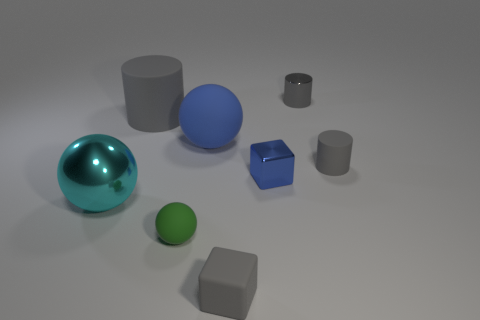Subtract all rubber balls. How many balls are left? 1 Add 2 large gray matte objects. How many objects exist? 10 Subtract all balls. How many objects are left? 5 Subtract all green spheres. Subtract all red cubes. How many spheres are left? 2 Subtract all cyan cylinders. Subtract all rubber cubes. How many objects are left? 7 Add 7 tiny metallic cylinders. How many tiny metallic cylinders are left? 8 Add 4 tiny cubes. How many tiny cubes exist? 6 Subtract 0 purple spheres. How many objects are left? 8 